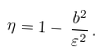<formula> <loc_0><loc_0><loc_500><loc_500>\eta = 1 - \, \frac { b ^ { 2 } } { \varepsilon ^ { 2 } } \, .</formula> 